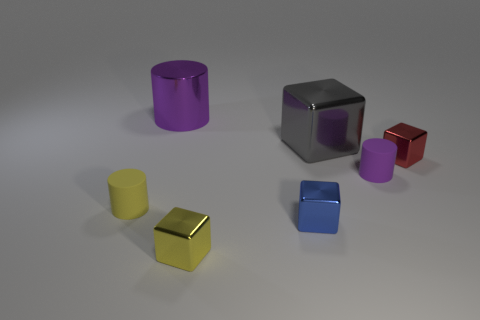What is the material of the tiny yellow object on the right side of the purple object that is behind the tiny red shiny cube?
Provide a succinct answer. Metal. Is the large object on the left side of the blue block made of the same material as the red cube?
Your answer should be compact. Yes. What is the size of the purple cylinder on the left side of the purple matte cylinder?
Provide a succinct answer. Large. Is there a metal block that is on the left side of the purple thing that is right of the large cylinder?
Provide a succinct answer. Yes. Is the color of the matte object to the left of the tiny yellow shiny cube the same as the metallic block to the left of the blue object?
Offer a terse response. Yes. What color is the shiny cylinder?
Offer a terse response. Purple. Are there any other things of the same color as the big cube?
Give a very brief answer. No. There is a thing that is both left of the blue metal object and behind the tiny purple rubber cylinder; what is its color?
Your answer should be compact. Purple. Is the size of the matte cylinder that is to the right of the yellow metal block the same as the red block?
Provide a short and direct response. Yes. Is the number of small rubber objects to the left of the large purple metallic object greater than the number of big rubber cylinders?
Your answer should be compact. Yes. 